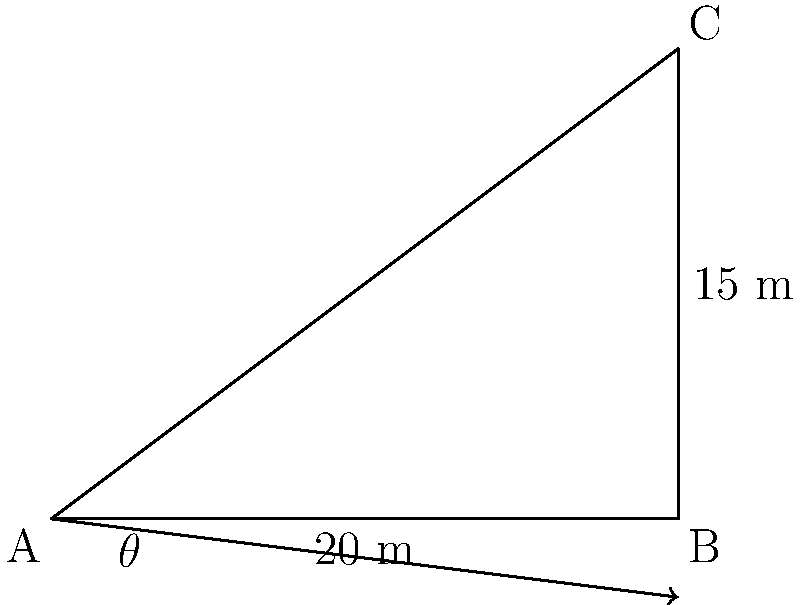In this alternative assessment, imagine you're on a field trip with your students. You want to demonstrate how math can be applied in real-world situations. Using the diagram provided, which represents a simple method to estimate the angle of elevation of a tree, calculate the angle $\theta$. The distance from the observer (point A) to the base of the tree (point B) is 20 meters, and a student holding a clinometer at eye level (point C) is 15 meters above the ground. How would you guide your students to find the angle of elevation without relying on traditional exam methods? To guide students in finding the angle of elevation without relying on traditional exam methods, we can encourage a more intuitive and practical approach:

1. Recognize the right triangle formed by the observer (A), the base of the tree (B), and the top of the tree (C).

2. Identify the known measurements:
   - Adjacent side (AB) = 20 meters
   - Opposite side (BC) = 15 meters

3. Discuss how these measurements relate to the angle we're trying to find.

4. Introduce the concept of the tangent ratio in a right triangle:
   $\tan(\theta) = \frac{\text{opposite}}{\text{adjacent}}$

5. Apply this concept to our scenario:
   $\tan(\theta) = \frac{15}{20} = 0.75$

6. Instead of immediately solving for $\theta$, encourage students to estimate the angle based on this ratio.

7. Use a hands-on approach: have students create a physical model of the triangle and measure the angle directly.

8. Compare their estimates and measurements with the calculated value:
   $\theta = \arctan(0.75) \approx 36.87°$

9. Discuss the real-world implications of this angle and how it could be useful in various professions.

This approach emphasizes understanding, practical application, and estimation skills over rote calculation, aligning with the belief that traditional exams may not fully capture a student's comprehension.
Answer: $\theta \approx 36.87°$ 